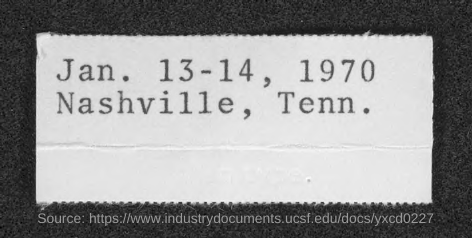Mention a couple of crucial points in this snapshot. The document states that the date is January 13th and 14th of 1970. 